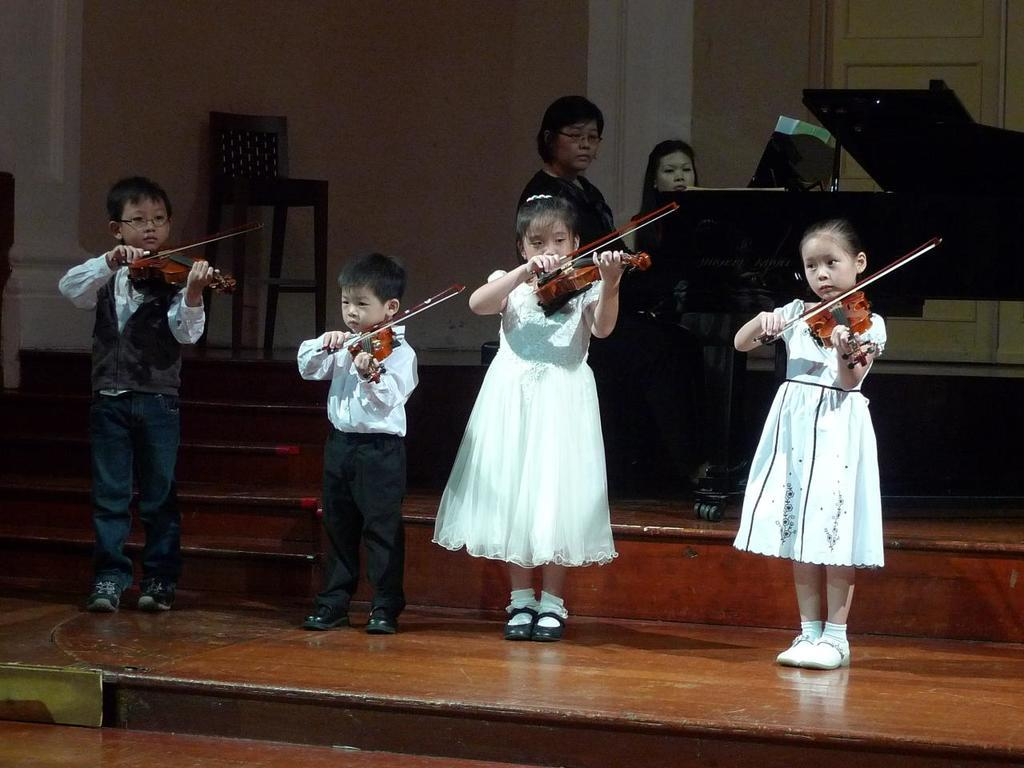How many kids are present in the image? There are 4 kids in the image. What are the kids holding in the image? Each kid is holding a violin. Can you describe the background of the image? There are 2 women in the background of the image, sitting in front of a piano, and there is a wall in the background as well. What type of engine can be seen in the image? There is no engine present in the image. What kind of humor is being displayed by the kids in the image? The image does not depict any humor; it shows kids holding violins. 